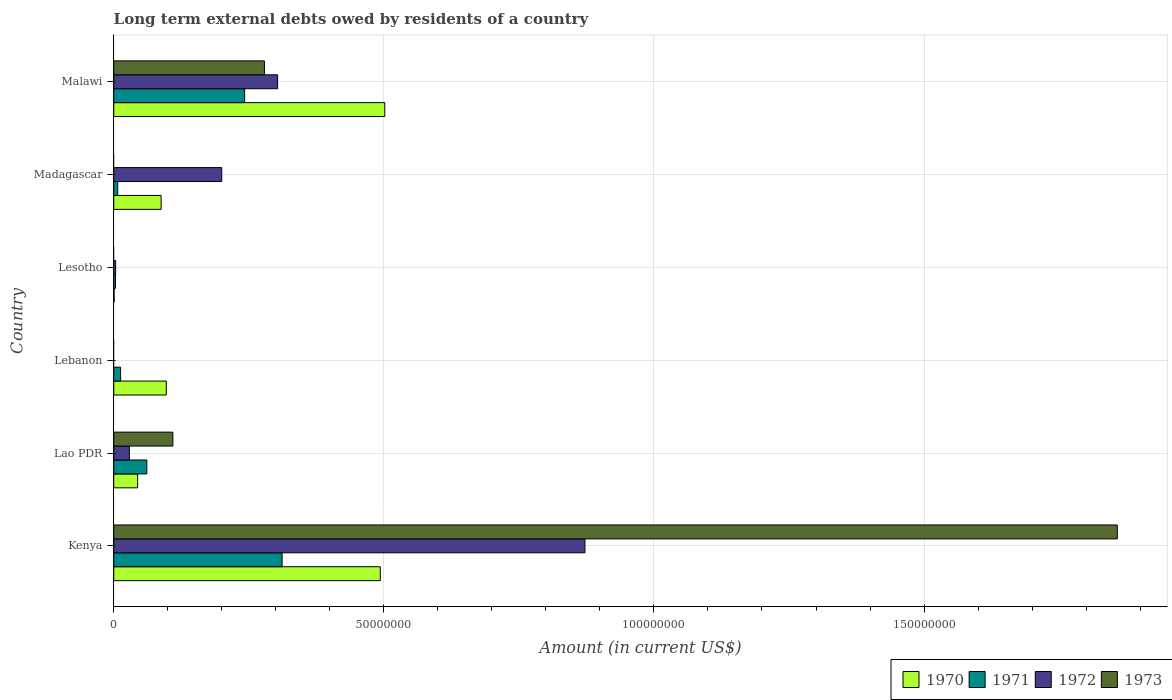How many different coloured bars are there?
Keep it short and to the point. 4. Are the number of bars per tick equal to the number of legend labels?
Provide a short and direct response. No. Are the number of bars on each tick of the Y-axis equal?
Ensure brevity in your answer.  No. How many bars are there on the 6th tick from the top?
Give a very brief answer. 4. What is the label of the 1st group of bars from the top?
Offer a very short reply. Malawi. In how many cases, is the number of bars for a given country not equal to the number of legend labels?
Offer a very short reply. 3. What is the amount of long-term external debts owed by residents in 1971 in Lao PDR?
Offer a very short reply. 6.12e+06. Across all countries, what is the maximum amount of long-term external debts owed by residents in 1972?
Keep it short and to the point. 8.72e+07. Across all countries, what is the minimum amount of long-term external debts owed by residents in 1970?
Make the answer very short. 7.60e+04. In which country was the amount of long-term external debts owed by residents in 1972 maximum?
Provide a succinct answer. Kenya. What is the total amount of long-term external debts owed by residents in 1972 in the graph?
Keep it short and to the point. 1.41e+08. What is the difference between the amount of long-term external debts owed by residents in 1972 in Lesotho and that in Malawi?
Provide a succinct answer. -3.00e+07. What is the difference between the amount of long-term external debts owed by residents in 1970 in Kenya and the amount of long-term external debts owed by residents in 1972 in Lebanon?
Give a very brief answer. 4.93e+07. What is the average amount of long-term external debts owed by residents in 1971 per country?
Your answer should be very brief. 1.06e+07. What is the difference between the amount of long-term external debts owed by residents in 1970 and amount of long-term external debts owed by residents in 1972 in Madagascar?
Offer a terse response. -1.12e+07. What is the ratio of the amount of long-term external debts owed by residents in 1970 in Lao PDR to that in Lebanon?
Your response must be concise. 0.45. Is the difference between the amount of long-term external debts owed by residents in 1970 in Kenya and Malawi greater than the difference between the amount of long-term external debts owed by residents in 1972 in Kenya and Malawi?
Offer a terse response. No. What is the difference between the highest and the second highest amount of long-term external debts owed by residents in 1971?
Make the answer very short. 6.94e+06. What is the difference between the highest and the lowest amount of long-term external debts owed by residents in 1973?
Keep it short and to the point. 1.86e+08. In how many countries, is the amount of long-term external debts owed by residents in 1971 greater than the average amount of long-term external debts owed by residents in 1971 taken over all countries?
Offer a terse response. 2. Is it the case that in every country, the sum of the amount of long-term external debts owed by residents in 1972 and amount of long-term external debts owed by residents in 1971 is greater than the sum of amount of long-term external debts owed by residents in 1973 and amount of long-term external debts owed by residents in 1970?
Make the answer very short. No. Is it the case that in every country, the sum of the amount of long-term external debts owed by residents in 1971 and amount of long-term external debts owed by residents in 1970 is greater than the amount of long-term external debts owed by residents in 1973?
Keep it short and to the point. No. How many bars are there?
Ensure brevity in your answer.  20. Are all the bars in the graph horizontal?
Provide a succinct answer. Yes. What is the difference between two consecutive major ticks on the X-axis?
Your answer should be very brief. 5.00e+07. Does the graph contain any zero values?
Offer a very short reply. Yes. Does the graph contain grids?
Give a very brief answer. Yes. How many legend labels are there?
Provide a short and direct response. 4. How are the legend labels stacked?
Provide a short and direct response. Horizontal. What is the title of the graph?
Provide a short and direct response. Long term external debts owed by residents of a country. Does "2014" appear as one of the legend labels in the graph?
Ensure brevity in your answer.  No. What is the label or title of the X-axis?
Ensure brevity in your answer.  Amount (in current US$). What is the label or title of the Y-axis?
Your answer should be very brief. Country. What is the Amount (in current US$) of 1970 in Kenya?
Your response must be concise. 4.93e+07. What is the Amount (in current US$) in 1971 in Kenya?
Offer a terse response. 3.12e+07. What is the Amount (in current US$) in 1972 in Kenya?
Make the answer very short. 8.72e+07. What is the Amount (in current US$) of 1973 in Kenya?
Provide a short and direct response. 1.86e+08. What is the Amount (in current US$) of 1970 in Lao PDR?
Provide a short and direct response. 4.42e+06. What is the Amount (in current US$) of 1971 in Lao PDR?
Offer a terse response. 6.12e+06. What is the Amount (in current US$) of 1972 in Lao PDR?
Provide a short and direct response. 2.89e+06. What is the Amount (in current US$) of 1973 in Lao PDR?
Give a very brief answer. 1.09e+07. What is the Amount (in current US$) in 1970 in Lebanon?
Your answer should be compact. 9.73e+06. What is the Amount (in current US$) in 1971 in Lebanon?
Your response must be concise. 1.26e+06. What is the Amount (in current US$) in 1970 in Lesotho?
Provide a succinct answer. 7.60e+04. What is the Amount (in current US$) in 1971 in Lesotho?
Your answer should be very brief. 3.26e+05. What is the Amount (in current US$) in 1972 in Lesotho?
Your answer should be very brief. 3.48e+05. What is the Amount (in current US$) in 1973 in Lesotho?
Offer a terse response. 0. What is the Amount (in current US$) in 1970 in Madagascar?
Your answer should be compact. 8.78e+06. What is the Amount (in current US$) of 1971 in Madagascar?
Keep it short and to the point. 7.30e+05. What is the Amount (in current US$) of 1972 in Madagascar?
Offer a very short reply. 2.00e+07. What is the Amount (in current US$) of 1970 in Malawi?
Keep it short and to the point. 5.02e+07. What is the Amount (in current US$) in 1971 in Malawi?
Provide a succinct answer. 2.42e+07. What is the Amount (in current US$) in 1972 in Malawi?
Offer a very short reply. 3.03e+07. What is the Amount (in current US$) in 1973 in Malawi?
Your answer should be compact. 2.79e+07. Across all countries, what is the maximum Amount (in current US$) of 1970?
Offer a terse response. 5.02e+07. Across all countries, what is the maximum Amount (in current US$) of 1971?
Your answer should be compact. 3.12e+07. Across all countries, what is the maximum Amount (in current US$) of 1972?
Provide a short and direct response. 8.72e+07. Across all countries, what is the maximum Amount (in current US$) of 1973?
Give a very brief answer. 1.86e+08. Across all countries, what is the minimum Amount (in current US$) of 1970?
Give a very brief answer. 7.60e+04. Across all countries, what is the minimum Amount (in current US$) in 1971?
Provide a succinct answer. 3.26e+05. What is the total Amount (in current US$) of 1970 in the graph?
Make the answer very short. 1.23e+08. What is the total Amount (in current US$) of 1971 in the graph?
Offer a terse response. 6.38e+07. What is the total Amount (in current US$) of 1972 in the graph?
Provide a short and direct response. 1.41e+08. What is the total Amount (in current US$) of 1973 in the graph?
Your response must be concise. 2.25e+08. What is the difference between the Amount (in current US$) of 1970 in Kenya and that in Lao PDR?
Provide a short and direct response. 4.49e+07. What is the difference between the Amount (in current US$) of 1971 in Kenya and that in Lao PDR?
Your answer should be compact. 2.50e+07. What is the difference between the Amount (in current US$) of 1972 in Kenya and that in Lao PDR?
Offer a terse response. 8.43e+07. What is the difference between the Amount (in current US$) of 1973 in Kenya and that in Lao PDR?
Give a very brief answer. 1.75e+08. What is the difference between the Amount (in current US$) of 1970 in Kenya and that in Lebanon?
Your answer should be compact. 3.96e+07. What is the difference between the Amount (in current US$) in 1971 in Kenya and that in Lebanon?
Provide a short and direct response. 2.99e+07. What is the difference between the Amount (in current US$) in 1970 in Kenya and that in Lesotho?
Offer a very short reply. 4.93e+07. What is the difference between the Amount (in current US$) in 1971 in Kenya and that in Lesotho?
Make the answer very short. 3.08e+07. What is the difference between the Amount (in current US$) in 1972 in Kenya and that in Lesotho?
Give a very brief answer. 8.69e+07. What is the difference between the Amount (in current US$) in 1970 in Kenya and that in Madagascar?
Provide a short and direct response. 4.06e+07. What is the difference between the Amount (in current US$) in 1971 in Kenya and that in Madagascar?
Offer a very short reply. 3.04e+07. What is the difference between the Amount (in current US$) in 1972 in Kenya and that in Madagascar?
Offer a terse response. 6.72e+07. What is the difference between the Amount (in current US$) in 1970 in Kenya and that in Malawi?
Make the answer very short. -8.29e+05. What is the difference between the Amount (in current US$) in 1971 in Kenya and that in Malawi?
Keep it short and to the point. 6.94e+06. What is the difference between the Amount (in current US$) of 1972 in Kenya and that in Malawi?
Your response must be concise. 5.69e+07. What is the difference between the Amount (in current US$) of 1973 in Kenya and that in Malawi?
Ensure brevity in your answer.  1.58e+08. What is the difference between the Amount (in current US$) in 1970 in Lao PDR and that in Lebanon?
Your answer should be very brief. -5.30e+06. What is the difference between the Amount (in current US$) in 1971 in Lao PDR and that in Lebanon?
Keep it short and to the point. 4.86e+06. What is the difference between the Amount (in current US$) in 1970 in Lao PDR and that in Lesotho?
Your answer should be very brief. 4.35e+06. What is the difference between the Amount (in current US$) in 1971 in Lao PDR and that in Lesotho?
Keep it short and to the point. 5.80e+06. What is the difference between the Amount (in current US$) in 1972 in Lao PDR and that in Lesotho?
Provide a succinct answer. 2.54e+06. What is the difference between the Amount (in current US$) in 1970 in Lao PDR and that in Madagascar?
Offer a terse response. -4.35e+06. What is the difference between the Amount (in current US$) of 1971 in Lao PDR and that in Madagascar?
Provide a succinct answer. 5.39e+06. What is the difference between the Amount (in current US$) in 1972 in Lao PDR and that in Madagascar?
Offer a terse response. -1.71e+07. What is the difference between the Amount (in current US$) in 1970 in Lao PDR and that in Malawi?
Offer a very short reply. -4.58e+07. What is the difference between the Amount (in current US$) of 1971 in Lao PDR and that in Malawi?
Your answer should be compact. -1.81e+07. What is the difference between the Amount (in current US$) in 1972 in Lao PDR and that in Malawi?
Give a very brief answer. -2.74e+07. What is the difference between the Amount (in current US$) of 1973 in Lao PDR and that in Malawi?
Your answer should be compact. -1.70e+07. What is the difference between the Amount (in current US$) of 1970 in Lebanon and that in Lesotho?
Provide a succinct answer. 9.65e+06. What is the difference between the Amount (in current US$) of 1971 in Lebanon and that in Lesotho?
Your answer should be very brief. 9.39e+05. What is the difference between the Amount (in current US$) in 1970 in Lebanon and that in Madagascar?
Give a very brief answer. 9.51e+05. What is the difference between the Amount (in current US$) of 1971 in Lebanon and that in Madagascar?
Provide a short and direct response. 5.35e+05. What is the difference between the Amount (in current US$) of 1970 in Lebanon and that in Malawi?
Provide a succinct answer. -4.04e+07. What is the difference between the Amount (in current US$) in 1971 in Lebanon and that in Malawi?
Provide a succinct answer. -2.30e+07. What is the difference between the Amount (in current US$) of 1970 in Lesotho and that in Madagascar?
Your answer should be compact. -8.70e+06. What is the difference between the Amount (in current US$) of 1971 in Lesotho and that in Madagascar?
Keep it short and to the point. -4.04e+05. What is the difference between the Amount (in current US$) in 1972 in Lesotho and that in Madagascar?
Keep it short and to the point. -1.96e+07. What is the difference between the Amount (in current US$) in 1970 in Lesotho and that in Malawi?
Your response must be concise. -5.01e+07. What is the difference between the Amount (in current US$) in 1971 in Lesotho and that in Malawi?
Make the answer very short. -2.39e+07. What is the difference between the Amount (in current US$) in 1972 in Lesotho and that in Malawi?
Your answer should be very brief. -3.00e+07. What is the difference between the Amount (in current US$) of 1970 in Madagascar and that in Malawi?
Provide a short and direct response. -4.14e+07. What is the difference between the Amount (in current US$) of 1971 in Madagascar and that in Malawi?
Offer a terse response. -2.35e+07. What is the difference between the Amount (in current US$) of 1972 in Madagascar and that in Malawi?
Make the answer very short. -1.03e+07. What is the difference between the Amount (in current US$) in 1970 in Kenya and the Amount (in current US$) in 1971 in Lao PDR?
Ensure brevity in your answer.  4.32e+07. What is the difference between the Amount (in current US$) in 1970 in Kenya and the Amount (in current US$) in 1972 in Lao PDR?
Offer a terse response. 4.65e+07. What is the difference between the Amount (in current US$) of 1970 in Kenya and the Amount (in current US$) of 1973 in Lao PDR?
Your answer should be very brief. 3.84e+07. What is the difference between the Amount (in current US$) in 1971 in Kenya and the Amount (in current US$) in 1972 in Lao PDR?
Your answer should be very brief. 2.83e+07. What is the difference between the Amount (in current US$) of 1971 in Kenya and the Amount (in current US$) of 1973 in Lao PDR?
Your answer should be very brief. 2.02e+07. What is the difference between the Amount (in current US$) of 1972 in Kenya and the Amount (in current US$) of 1973 in Lao PDR?
Provide a short and direct response. 7.63e+07. What is the difference between the Amount (in current US$) in 1970 in Kenya and the Amount (in current US$) in 1971 in Lebanon?
Your response must be concise. 4.81e+07. What is the difference between the Amount (in current US$) in 1970 in Kenya and the Amount (in current US$) in 1971 in Lesotho?
Your answer should be very brief. 4.90e+07. What is the difference between the Amount (in current US$) of 1970 in Kenya and the Amount (in current US$) of 1972 in Lesotho?
Keep it short and to the point. 4.90e+07. What is the difference between the Amount (in current US$) of 1971 in Kenya and the Amount (in current US$) of 1972 in Lesotho?
Keep it short and to the point. 3.08e+07. What is the difference between the Amount (in current US$) in 1970 in Kenya and the Amount (in current US$) in 1971 in Madagascar?
Provide a succinct answer. 4.86e+07. What is the difference between the Amount (in current US$) of 1970 in Kenya and the Amount (in current US$) of 1972 in Madagascar?
Ensure brevity in your answer.  2.94e+07. What is the difference between the Amount (in current US$) of 1971 in Kenya and the Amount (in current US$) of 1972 in Madagascar?
Your response must be concise. 1.12e+07. What is the difference between the Amount (in current US$) of 1970 in Kenya and the Amount (in current US$) of 1971 in Malawi?
Keep it short and to the point. 2.51e+07. What is the difference between the Amount (in current US$) in 1970 in Kenya and the Amount (in current US$) in 1972 in Malawi?
Your response must be concise. 1.90e+07. What is the difference between the Amount (in current US$) of 1970 in Kenya and the Amount (in current US$) of 1973 in Malawi?
Offer a very short reply. 2.14e+07. What is the difference between the Amount (in current US$) of 1971 in Kenya and the Amount (in current US$) of 1972 in Malawi?
Provide a short and direct response. 8.33e+05. What is the difference between the Amount (in current US$) of 1971 in Kenya and the Amount (in current US$) of 1973 in Malawi?
Provide a succinct answer. 3.27e+06. What is the difference between the Amount (in current US$) in 1972 in Kenya and the Amount (in current US$) in 1973 in Malawi?
Offer a terse response. 5.93e+07. What is the difference between the Amount (in current US$) in 1970 in Lao PDR and the Amount (in current US$) in 1971 in Lebanon?
Offer a terse response. 3.16e+06. What is the difference between the Amount (in current US$) of 1970 in Lao PDR and the Amount (in current US$) of 1971 in Lesotho?
Your response must be concise. 4.10e+06. What is the difference between the Amount (in current US$) in 1970 in Lao PDR and the Amount (in current US$) in 1972 in Lesotho?
Offer a terse response. 4.08e+06. What is the difference between the Amount (in current US$) in 1971 in Lao PDR and the Amount (in current US$) in 1972 in Lesotho?
Your answer should be very brief. 5.78e+06. What is the difference between the Amount (in current US$) of 1970 in Lao PDR and the Amount (in current US$) of 1971 in Madagascar?
Your answer should be very brief. 3.69e+06. What is the difference between the Amount (in current US$) in 1970 in Lao PDR and the Amount (in current US$) in 1972 in Madagascar?
Ensure brevity in your answer.  -1.56e+07. What is the difference between the Amount (in current US$) of 1971 in Lao PDR and the Amount (in current US$) of 1972 in Madagascar?
Keep it short and to the point. -1.39e+07. What is the difference between the Amount (in current US$) in 1970 in Lao PDR and the Amount (in current US$) in 1971 in Malawi?
Your answer should be compact. -1.98e+07. What is the difference between the Amount (in current US$) of 1970 in Lao PDR and the Amount (in current US$) of 1972 in Malawi?
Provide a succinct answer. -2.59e+07. What is the difference between the Amount (in current US$) of 1970 in Lao PDR and the Amount (in current US$) of 1973 in Malawi?
Your answer should be very brief. -2.35e+07. What is the difference between the Amount (in current US$) of 1971 in Lao PDR and the Amount (in current US$) of 1972 in Malawi?
Make the answer very short. -2.42e+07. What is the difference between the Amount (in current US$) of 1971 in Lao PDR and the Amount (in current US$) of 1973 in Malawi?
Offer a very short reply. -2.18e+07. What is the difference between the Amount (in current US$) in 1972 in Lao PDR and the Amount (in current US$) in 1973 in Malawi?
Your answer should be compact. -2.50e+07. What is the difference between the Amount (in current US$) of 1970 in Lebanon and the Amount (in current US$) of 1971 in Lesotho?
Make the answer very short. 9.40e+06. What is the difference between the Amount (in current US$) in 1970 in Lebanon and the Amount (in current US$) in 1972 in Lesotho?
Your response must be concise. 9.38e+06. What is the difference between the Amount (in current US$) of 1971 in Lebanon and the Amount (in current US$) of 1972 in Lesotho?
Give a very brief answer. 9.17e+05. What is the difference between the Amount (in current US$) in 1970 in Lebanon and the Amount (in current US$) in 1971 in Madagascar?
Make the answer very short. 9.00e+06. What is the difference between the Amount (in current US$) of 1970 in Lebanon and the Amount (in current US$) of 1972 in Madagascar?
Provide a succinct answer. -1.03e+07. What is the difference between the Amount (in current US$) of 1971 in Lebanon and the Amount (in current US$) of 1972 in Madagascar?
Your answer should be compact. -1.87e+07. What is the difference between the Amount (in current US$) in 1970 in Lebanon and the Amount (in current US$) in 1971 in Malawi?
Your response must be concise. -1.45e+07. What is the difference between the Amount (in current US$) of 1970 in Lebanon and the Amount (in current US$) of 1972 in Malawi?
Make the answer very short. -2.06e+07. What is the difference between the Amount (in current US$) of 1970 in Lebanon and the Amount (in current US$) of 1973 in Malawi?
Make the answer very short. -1.82e+07. What is the difference between the Amount (in current US$) of 1971 in Lebanon and the Amount (in current US$) of 1972 in Malawi?
Provide a short and direct response. -2.91e+07. What is the difference between the Amount (in current US$) in 1971 in Lebanon and the Amount (in current US$) in 1973 in Malawi?
Give a very brief answer. -2.66e+07. What is the difference between the Amount (in current US$) in 1970 in Lesotho and the Amount (in current US$) in 1971 in Madagascar?
Provide a short and direct response. -6.54e+05. What is the difference between the Amount (in current US$) of 1970 in Lesotho and the Amount (in current US$) of 1972 in Madagascar?
Ensure brevity in your answer.  -1.99e+07. What is the difference between the Amount (in current US$) of 1971 in Lesotho and the Amount (in current US$) of 1972 in Madagascar?
Your response must be concise. -1.97e+07. What is the difference between the Amount (in current US$) of 1970 in Lesotho and the Amount (in current US$) of 1971 in Malawi?
Provide a short and direct response. -2.42e+07. What is the difference between the Amount (in current US$) in 1970 in Lesotho and the Amount (in current US$) in 1972 in Malawi?
Make the answer very short. -3.03e+07. What is the difference between the Amount (in current US$) of 1970 in Lesotho and the Amount (in current US$) of 1973 in Malawi?
Ensure brevity in your answer.  -2.78e+07. What is the difference between the Amount (in current US$) in 1971 in Lesotho and the Amount (in current US$) in 1972 in Malawi?
Provide a short and direct response. -3.00e+07. What is the difference between the Amount (in current US$) of 1971 in Lesotho and the Amount (in current US$) of 1973 in Malawi?
Offer a very short reply. -2.76e+07. What is the difference between the Amount (in current US$) of 1972 in Lesotho and the Amount (in current US$) of 1973 in Malawi?
Offer a very short reply. -2.76e+07. What is the difference between the Amount (in current US$) in 1970 in Madagascar and the Amount (in current US$) in 1971 in Malawi?
Your answer should be very brief. -1.55e+07. What is the difference between the Amount (in current US$) of 1970 in Madagascar and the Amount (in current US$) of 1972 in Malawi?
Offer a very short reply. -2.16e+07. What is the difference between the Amount (in current US$) in 1970 in Madagascar and the Amount (in current US$) in 1973 in Malawi?
Your answer should be very brief. -1.91e+07. What is the difference between the Amount (in current US$) of 1971 in Madagascar and the Amount (in current US$) of 1972 in Malawi?
Provide a succinct answer. -2.96e+07. What is the difference between the Amount (in current US$) of 1971 in Madagascar and the Amount (in current US$) of 1973 in Malawi?
Provide a succinct answer. -2.72e+07. What is the difference between the Amount (in current US$) of 1972 in Madagascar and the Amount (in current US$) of 1973 in Malawi?
Offer a terse response. -7.91e+06. What is the average Amount (in current US$) in 1970 per country?
Make the answer very short. 2.04e+07. What is the average Amount (in current US$) of 1971 per country?
Offer a very short reply. 1.06e+07. What is the average Amount (in current US$) in 1972 per country?
Your answer should be very brief. 2.35e+07. What is the average Amount (in current US$) in 1973 per country?
Provide a succinct answer. 3.74e+07. What is the difference between the Amount (in current US$) of 1970 and Amount (in current US$) of 1971 in Kenya?
Provide a short and direct response. 1.82e+07. What is the difference between the Amount (in current US$) in 1970 and Amount (in current US$) in 1972 in Kenya?
Give a very brief answer. -3.79e+07. What is the difference between the Amount (in current US$) in 1970 and Amount (in current US$) in 1973 in Kenya?
Provide a succinct answer. -1.36e+08. What is the difference between the Amount (in current US$) in 1971 and Amount (in current US$) in 1972 in Kenya?
Make the answer very short. -5.61e+07. What is the difference between the Amount (in current US$) of 1971 and Amount (in current US$) of 1973 in Kenya?
Your answer should be very brief. -1.55e+08. What is the difference between the Amount (in current US$) in 1972 and Amount (in current US$) in 1973 in Kenya?
Offer a very short reply. -9.86e+07. What is the difference between the Amount (in current US$) of 1970 and Amount (in current US$) of 1971 in Lao PDR?
Your answer should be compact. -1.70e+06. What is the difference between the Amount (in current US$) in 1970 and Amount (in current US$) in 1972 in Lao PDR?
Ensure brevity in your answer.  1.53e+06. What is the difference between the Amount (in current US$) in 1970 and Amount (in current US$) in 1973 in Lao PDR?
Ensure brevity in your answer.  -6.52e+06. What is the difference between the Amount (in current US$) of 1971 and Amount (in current US$) of 1972 in Lao PDR?
Provide a short and direct response. 3.23e+06. What is the difference between the Amount (in current US$) in 1971 and Amount (in current US$) in 1973 in Lao PDR?
Offer a terse response. -4.82e+06. What is the difference between the Amount (in current US$) in 1972 and Amount (in current US$) in 1973 in Lao PDR?
Provide a short and direct response. -8.06e+06. What is the difference between the Amount (in current US$) of 1970 and Amount (in current US$) of 1971 in Lebanon?
Your answer should be very brief. 8.46e+06. What is the difference between the Amount (in current US$) in 1970 and Amount (in current US$) in 1971 in Lesotho?
Provide a succinct answer. -2.50e+05. What is the difference between the Amount (in current US$) of 1970 and Amount (in current US$) of 1972 in Lesotho?
Give a very brief answer. -2.72e+05. What is the difference between the Amount (in current US$) of 1971 and Amount (in current US$) of 1972 in Lesotho?
Make the answer very short. -2.20e+04. What is the difference between the Amount (in current US$) of 1970 and Amount (in current US$) of 1971 in Madagascar?
Your answer should be compact. 8.04e+06. What is the difference between the Amount (in current US$) of 1970 and Amount (in current US$) of 1972 in Madagascar?
Your response must be concise. -1.12e+07. What is the difference between the Amount (in current US$) in 1971 and Amount (in current US$) in 1972 in Madagascar?
Offer a very short reply. -1.93e+07. What is the difference between the Amount (in current US$) of 1970 and Amount (in current US$) of 1971 in Malawi?
Give a very brief answer. 2.59e+07. What is the difference between the Amount (in current US$) in 1970 and Amount (in current US$) in 1972 in Malawi?
Provide a short and direct response. 1.98e+07. What is the difference between the Amount (in current US$) of 1970 and Amount (in current US$) of 1973 in Malawi?
Provide a succinct answer. 2.23e+07. What is the difference between the Amount (in current US$) of 1971 and Amount (in current US$) of 1972 in Malawi?
Give a very brief answer. -6.11e+06. What is the difference between the Amount (in current US$) in 1971 and Amount (in current US$) in 1973 in Malawi?
Provide a short and direct response. -3.67e+06. What is the difference between the Amount (in current US$) of 1972 and Amount (in current US$) of 1973 in Malawi?
Offer a very short reply. 2.43e+06. What is the ratio of the Amount (in current US$) of 1970 in Kenya to that in Lao PDR?
Offer a very short reply. 11.15. What is the ratio of the Amount (in current US$) in 1971 in Kenya to that in Lao PDR?
Offer a very short reply. 5.09. What is the ratio of the Amount (in current US$) in 1972 in Kenya to that in Lao PDR?
Your answer should be compact. 30.16. What is the ratio of the Amount (in current US$) in 1973 in Kenya to that in Lao PDR?
Give a very brief answer. 16.97. What is the ratio of the Amount (in current US$) of 1970 in Kenya to that in Lebanon?
Your answer should be compact. 5.07. What is the ratio of the Amount (in current US$) of 1971 in Kenya to that in Lebanon?
Keep it short and to the point. 24.64. What is the ratio of the Amount (in current US$) in 1970 in Kenya to that in Lesotho?
Make the answer very short. 649.28. What is the ratio of the Amount (in current US$) in 1971 in Kenya to that in Lesotho?
Give a very brief answer. 95.6. What is the ratio of the Amount (in current US$) of 1972 in Kenya to that in Lesotho?
Offer a terse response. 250.66. What is the ratio of the Amount (in current US$) of 1970 in Kenya to that in Madagascar?
Give a very brief answer. 5.62. What is the ratio of the Amount (in current US$) in 1971 in Kenya to that in Madagascar?
Provide a succinct answer. 42.69. What is the ratio of the Amount (in current US$) of 1972 in Kenya to that in Madagascar?
Provide a succinct answer. 4.36. What is the ratio of the Amount (in current US$) in 1970 in Kenya to that in Malawi?
Keep it short and to the point. 0.98. What is the ratio of the Amount (in current US$) of 1971 in Kenya to that in Malawi?
Offer a terse response. 1.29. What is the ratio of the Amount (in current US$) in 1972 in Kenya to that in Malawi?
Keep it short and to the point. 2.88. What is the ratio of the Amount (in current US$) in 1973 in Kenya to that in Malawi?
Make the answer very short. 6.66. What is the ratio of the Amount (in current US$) of 1970 in Lao PDR to that in Lebanon?
Offer a very short reply. 0.45. What is the ratio of the Amount (in current US$) in 1971 in Lao PDR to that in Lebanon?
Keep it short and to the point. 4.84. What is the ratio of the Amount (in current US$) in 1970 in Lao PDR to that in Lesotho?
Keep it short and to the point. 58.21. What is the ratio of the Amount (in current US$) in 1971 in Lao PDR to that in Lesotho?
Keep it short and to the point. 18.79. What is the ratio of the Amount (in current US$) of 1972 in Lao PDR to that in Lesotho?
Give a very brief answer. 8.31. What is the ratio of the Amount (in current US$) in 1970 in Lao PDR to that in Madagascar?
Make the answer very short. 0.5. What is the ratio of the Amount (in current US$) of 1971 in Lao PDR to that in Madagascar?
Make the answer very short. 8.39. What is the ratio of the Amount (in current US$) of 1972 in Lao PDR to that in Madagascar?
Provide a short and direct response. 0.14. What is the ratio of the Amount (in current US$) in 1970 in Lao PDR to that in Malawi?
Keep it short and to the point. 0.09. What is the ratio of the Amount (in current US$) of 1971 in Lao PDR to that in Malawi?
Offer a very short reply. 0.25. What is the ratio of the Amount (in current US$) in 1972 in Lao PDR to that in Malawi?
Your response must be concise. 0.1. What is the ratio of the Amount (in current US$) of 1973 in Lao PDR to that in Malawi?
Provide a short and direct response. 0.39. What is the ratio of the Amount (in current US$) in 1970 in Lebanon to that in Lesotho?
Your response must be concise. 127.97. What is the ratio of the Amount (in current US$) in 1971 in Lebanon to that in Lesotho?
Make the answer very short. 3.88. What is the ratio of the Amount (in current US$) in 1970 in Lebanon to that in Madagascar?
Ensure brevity in your answer.  1.11. What is the ratio of the Amount (in current US$) in 1971 in Lebanon to that in Madagascar?
Offer a very short reply. 1.73. What is the ratio of the Amount (in current US$) in 1970 in Lebanon to that in Malawi?
Give a very brief answer. 0.19. What is the ratio of the Amount (in current US$) in 1971 in Lebanon to that in Malawi?
Your answer should be compact. 0.05. What is the ratio of the Amount (in current US$) in 1970 in Lesotho to that in Madagascar?
Offer a terse response. 0.01. What is the ratio of the Amount (in current US$) of 1971 in Lesotho to that in Madagascar?
Your answer should be very brief. 0.45. What is the ratio of the Amount (in current US$) of 1972 in Lesotho to that in Madagascar?
Offer a very short reply. 0.02. What is the ratio of the Amount (in current US$) of 1970 in Lesotho to that in Malawi?
Offer a terse response. 0. What is the ratio of the Amount (in current US$) in 1971 in Lesotho to that in Malawi?
Your answer should be very brief. 0.01. What is the ratio of the Amount (in current US$) in 1972 in Lesotho to that in Malawi?
Provide a succinct answer. 0.01. What is the ratio of the Amount (in current US$) of 1970 in Madagascar to that in Malawi?
Give a very brief answer. 0.17. What is the ratio of the Amount (in current US$) in 1971 in Madagascar to that in Malawi?
Provide a short and direct response. 0.03. What is the ratio of the Amount (in current US$) of 1972 in Madagascar to that in Malawi?
Offer a terse response. 0.66. What is the difference between the highest and the second highest Amount (in current US$) of 1970?
Offer a terse response. 8.29e+05. What is the difference between the highest and the second highest Amount (in current US$) in 1971?
Keep it short and to the point. 6.94e+06. What is the difference between the highest and the second highest Amount (in current US$) of 1972?
Your answer should be compact. 5.69e+07. What is the difference between the highest and the second highest Amount (in current US$) of 1973?
Make the answer very short. 1.58e+08. What is the difference between the highest and the lowest Amount (in current US$) of 1970?
Offer a very short reply. 5.01e+07. What is the difference between the highest and the lowest Amount (in current US$) of 1971?
Ensure brevity in your answer.  3.08e+07. What is the difference between the highest and the lowest Amount (in current US$) of 1972?
Offer a very short reply. 8.72e+07. What is the difference between the highest and the lowest Amount (in current US$) of 1973?
Your answer should be very brief. 1.86e+08. 